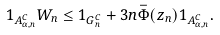Convert formula to latex. <formula><loc_0><loc_0><loc_500><loc_500>1 _ { A _ { \alpha , n } ^ { C } } W _ { n } \leq 1 _ { G _ { n } ^ { C } } + 3 n \bar { \Phi } ( z _ { n } ) 1 _ { A _ { \alpha , n } ^ { C } } .</formula> 